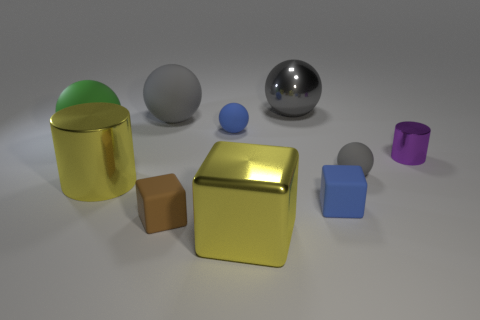How many things are either small red cubes or blue things to the left of the large metal sphere?
Your response must be concise. 1. Do the small cylinder and the big metallic thing that is in front of the large yellow cylinder have the same color?
Keep it short and to the point. No. How big is the thing that is both in front of the small purple metallic cylinder and right of the small blue matte block?
Offer a very short reply. Small. There is a large gray rubber ball; are there any blue blocks behind it?
Give a very brief answer. No. Is there a small purple cylinder that is to the left of the large gray object right of the blue ball?
Ensure brevity in your answer.  No. Are there the same number of big cylinders to the right of the big gray matte ball and metal blocks behind the tiny blue cube?
Ensure brevity in your answer.  Yes. What color is the other block that is the same material as the small blue block?
Offer a very short reply. Brown. Is there a tiny cylinder that has the same material as the small brown object?
Provide a succinct answer. No. What number of things are either tiny matte objects or small blue rubber objects?
Ensure brevity in your answer.  4. Is the material of the tiny blue cube the same as the large yellow thing that is behind the blue rubber block?
Keep it short and to the point. No. 